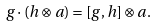Convert formula to latex. <formula><loc_0><loc_0><loc_500><loc_500>g \cdot ( h \otimes a ) = [ g , h ] \otimes a .</formula> 